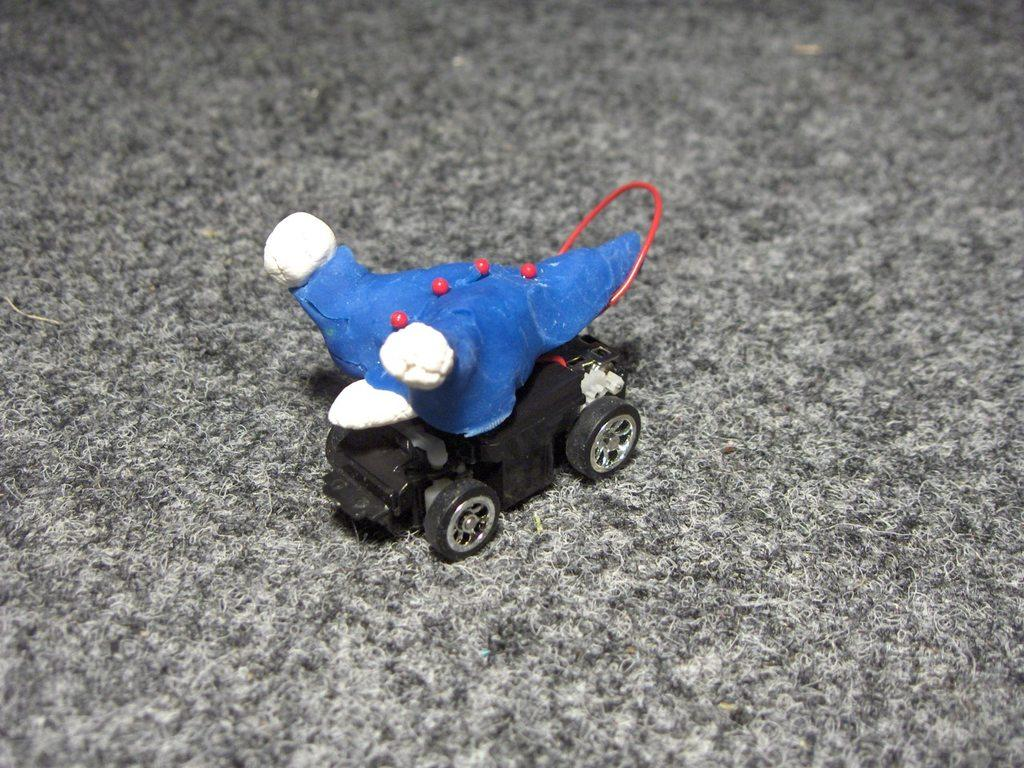What is the main object in the center of the image? There is a toy in the center of the image. What is located at the bottom of the image? There is a carpet at the bottom of the image. What type of tail can be seen on the toy in the image? There is no tail visible on the toy in the image. How is the carpet divided into sections in the image? The carpet is not divided into sections in the image; it appears as a single, continuous surface. 